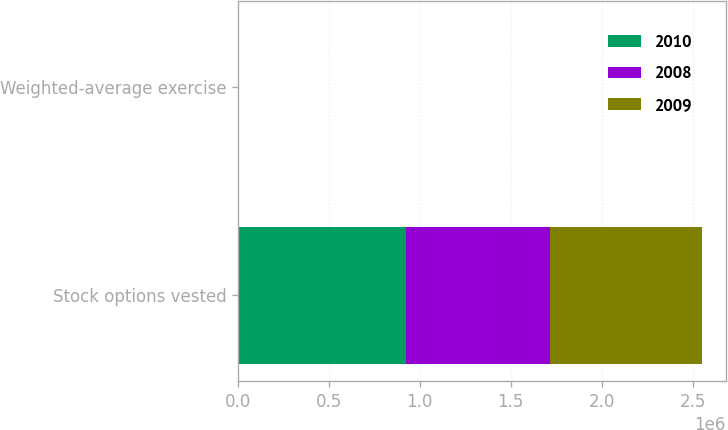<chart> <loc_0><loc_0><loc_500><loc_500><stacked_bar_chart><ecel><fcel>Stock options vested<fcel>Weighted-average exercise<nl><fcel>2010<fcel>922463<fcel>42.16<nl><fcel>2008<fcel>795566<fcel>46.86<nl><fcel>2009<fcel>835982<fcel>47.21<nl></chart> 